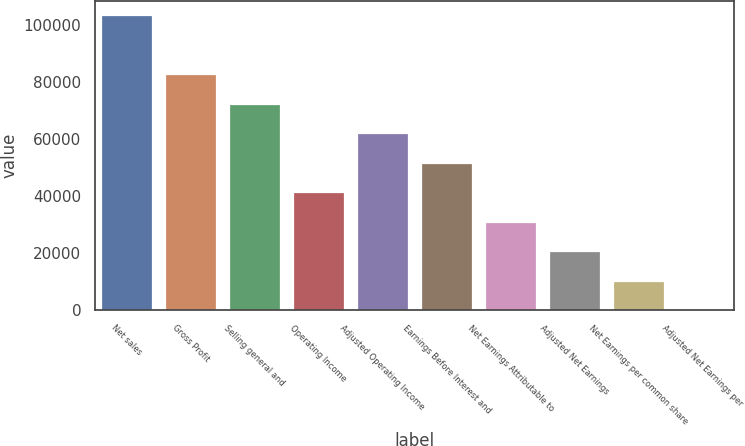Convert chart. <chart><loc_0><loc_0><loc_500><loc_500><bar_chart><fcel>Net sales<fcel>Gross Profit<fcel>Selling general and<fcel>Operating Income<fcel>Adjusted Operating Income<fcel>Earnings Before Interest and<fcel>Net Earnings Attributable to<fcel>Adjusted Net Earnings<fcel>Net Earnings per common share<fcel>Adjusted Net Earnings per<nl><fcel>103444<fcel>82756<fcel>72411.9<fcel>41379.9<fcel>62067.9<fcel>51723.9<fcel>31035.9<fcel>20691.9<fcel>10347.9<fcel>3.88<nl></chart> 